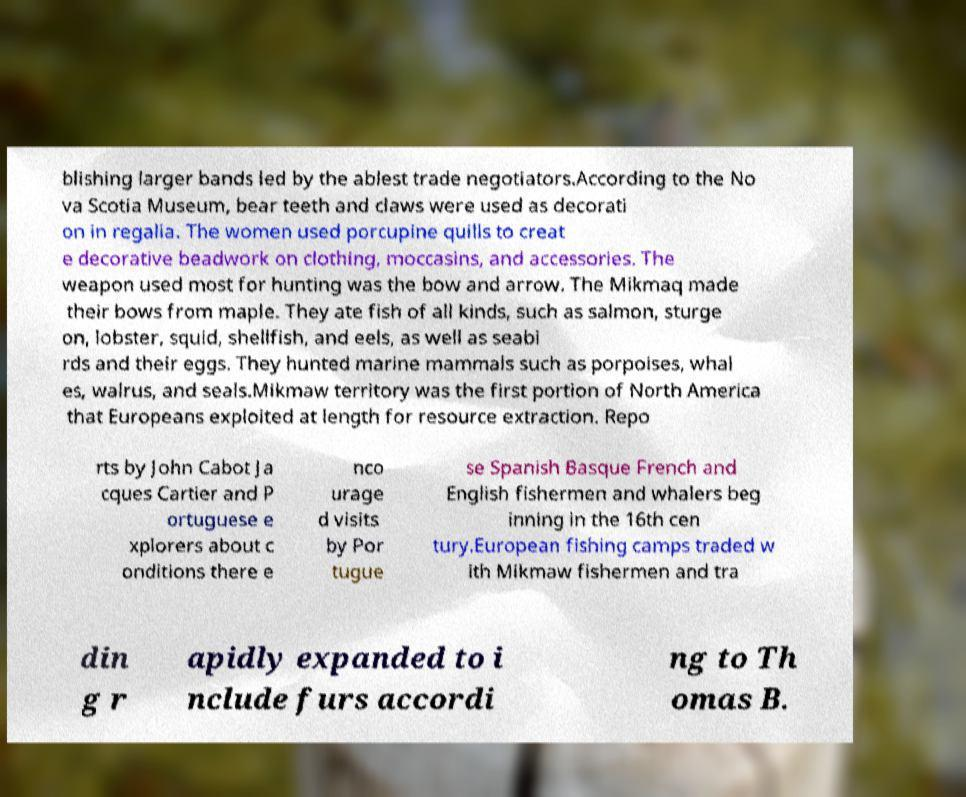There's text embedded in this image that I need extracted. Can you transcribe it verbatim? blishing larger bands led by the ablest trade negotiators.According to the No va Scotia Museum, bear teeth and claws were used as decorati on in regalia. The women used porcupine quills to creat e decorative beadwork on clothing, moccasins, and accessories. The weapon used most for hunting was the bow and arrow. The Mikmaq made their bows from maple. They ate fish of all kinds, such as salmon, sturge on, lobster, squid, shellfish, and eels, as well as seabi rds and their eggs. They hunted marine mammals such as porpoises, whal es, walrus, and seals.Mikmaw territory was the first portion of North America that Europeans exploited at length for resource extraction. Repo rts by John Cabot Ja cques Cartier and P ortuguese e xplorers about c onditions there e nco urage d visits by Por tugue se Spanish Basque French and English fishermen and whalers beg inning in the 16th cen tury.European fishing camps traded w ith Mikmaw fishermen and tra din g r apidly expanded to i nclude furs accordi ng to Th omas B. 